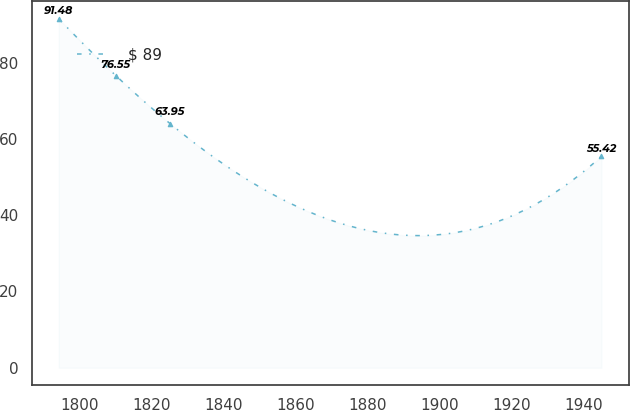Convert chart to OTSL. <chart><loc_0><loc_0><loc_500><loc_500><line_chart><ecel><fcel>$ 89<nl><fcel>1794.3<fcel>91.48<nl><fcel>1810.19<fcel>76.55<nl><fcel>1825.26<fcel>63.95<nl><fcel>1944.97<fcel>55.42<nl></chart> 